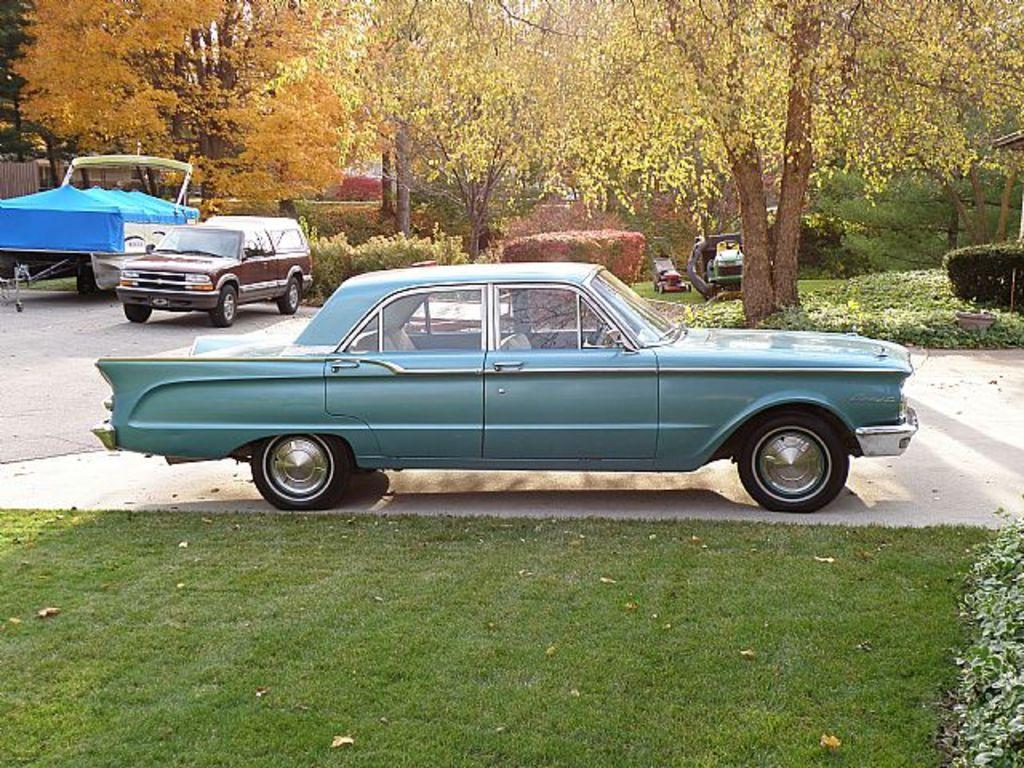What is the main subject in the center of the image? There are vehicles in the center of the image. What can be seen in the background of the image? There are trees in the background of the image. What type of vegetation is at the bottom of the image? There is grass at the bottom of the image. What other plants can be seen in the image besides trees? There are bushes visible in the image. What does the grandfather wish for in the image? There is no mention of a grandfather or any wishes in the image. 